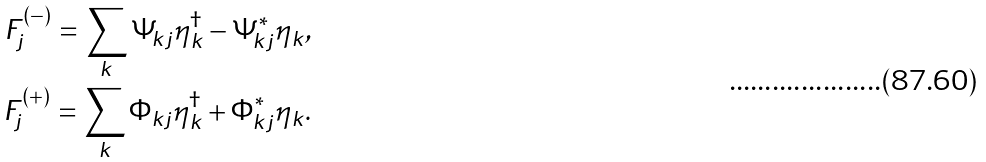<formula> <loc_0><loc_0><loc_500><loc_500>F _ { j } ^ { ( - ) } = \sum _ { k } \Psi _ { k j } \eta _ { k } ^ { \dagger } - \Psi _ { k j } ^ { * } \eta _ { k } , \\ F _ { j } ^ { ( + ) } = \sum _ { k } \Phi _ { k j } \eta _ { k } ^ { \dagger } + \Phi _ { k j } ^ { * } \eta _ { k } .</formula> 